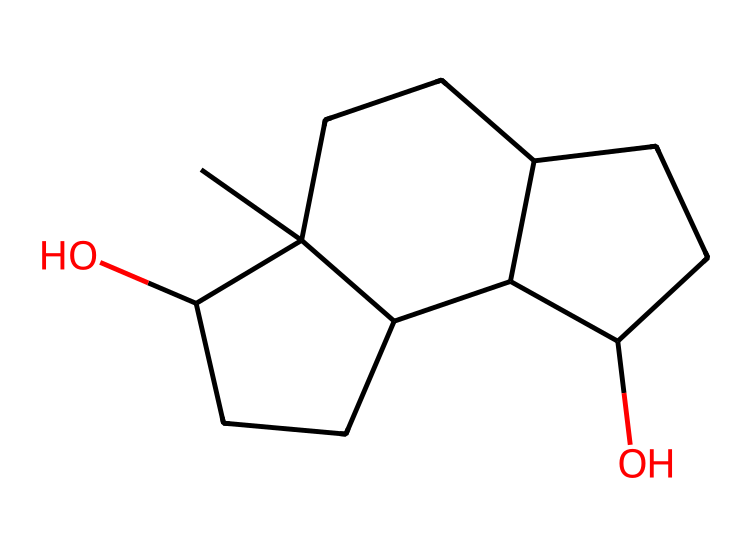What is the name of this chemical? The SMILES representation indicates the molecule is a form of estrogen, specifically 17β-estradiol, which is known to play a significant role in female reproductive health.
Answer: 17β-estradiol How many carbon atoms are present in the structure? By examining the SMILES notation, we can account for each carbon atom indicated. There are 15 carbon atoms in total in the structure.
Answer: 15 What is the functional group present in this chemical? The presence of -OH groups in the structure indicates that this chemical has hydroxyl functional groups, characteristic of alcohols and important for its activity as a hormone.
Answer: hydroxyl Is this chemical organic or inorganic? The presence of carbon and hydrogen in the structure indicates it is organic.
Answer: organic What role does this hormone play during menopause? Estrogen plays a significant role in regulating various bodily functions, including maintaining bone density and cardiovascular health, which are particularly impacted during menopause due to reduced levels.
Answer: regulates bodily functions How does the structure influence its hormonal activity? The specific arrangement of hydroxyl groups and the cyclic structure allows estrogen to bind effectively to estrogen receptors, facilitating its role as a hormone.
Answer: binds to receptors What type of hormone is this? This hormone is classified as a steroid hormone, which is derived from cholesterol and is crucial for various physiological processes.
Answer: steroid 